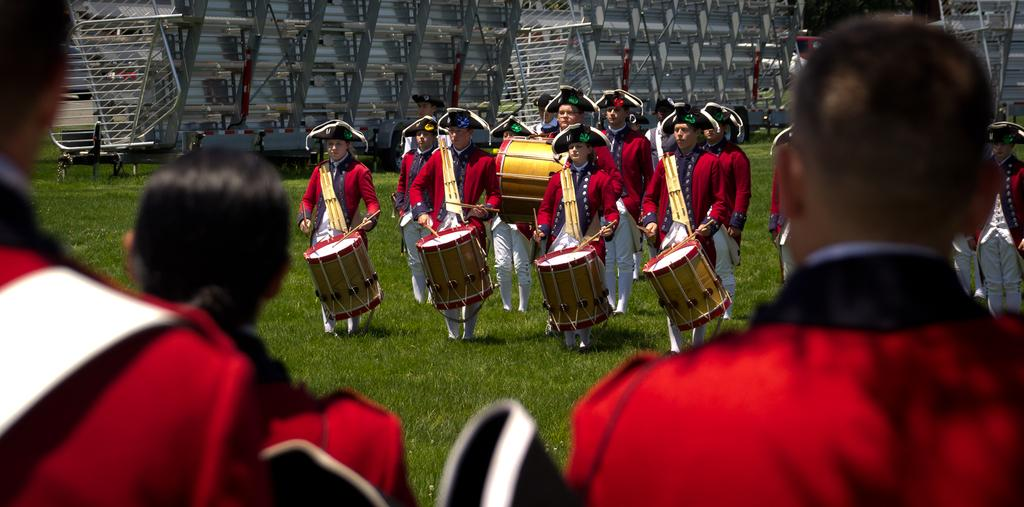Who or what can be seen in the image? There are people in the image. Where are the people located? The people are on the grass. What are most of the people doing in the image? Most of the people are holding musical instruments. Are there any other people in the image besides those holding musical instruments? Yes, there are a few additional people in the image. What type of coil is being used by the people in the image? There is no coil present in the image; the people are holding musical instruments. What grade level are the people in the image? The image does not provide information about the grade level of the people. 